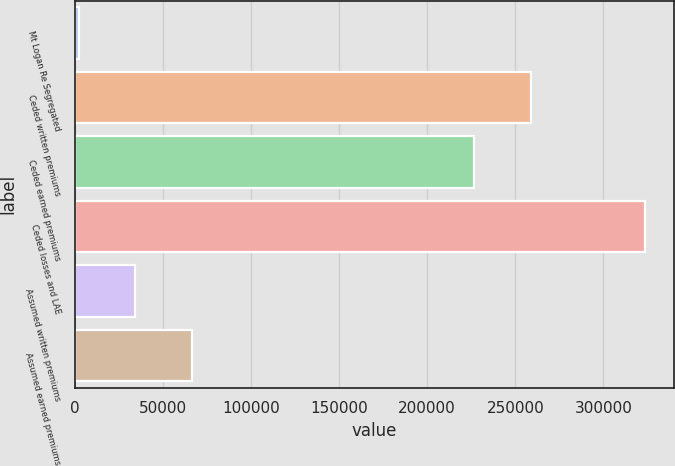Convert chart. <chart><loc_0><loc_0><loc_500><loc_500><bar_chart><fcel>Mt Logan Re Segregated<fcel>Ceded written premiums<fcel>Ceded earned premiums<fcel>Ceded losses and LAE<fcel>Assumed written premiums<fcel>Assumed earned premiums<nl><fcel>2017<fcel>258670<fcel>226505<fcel>323664<fcel>34181.7<fcel>66346.4<nl></chart> 